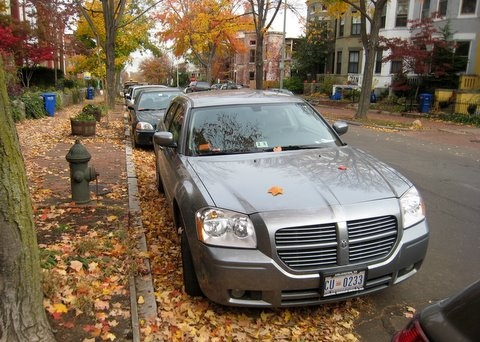Describe the objects in this image and their specific colors. I can see car in olive, darkgray, lightgray, black, and gray tones, car in olive, black, maroon, and gray tones, car in olive, darkgray, black, gray, and lightgray tones, fire hydrant in olive, black, and gray tones, and potted plant in olive, maroon, and black tones in this image. 